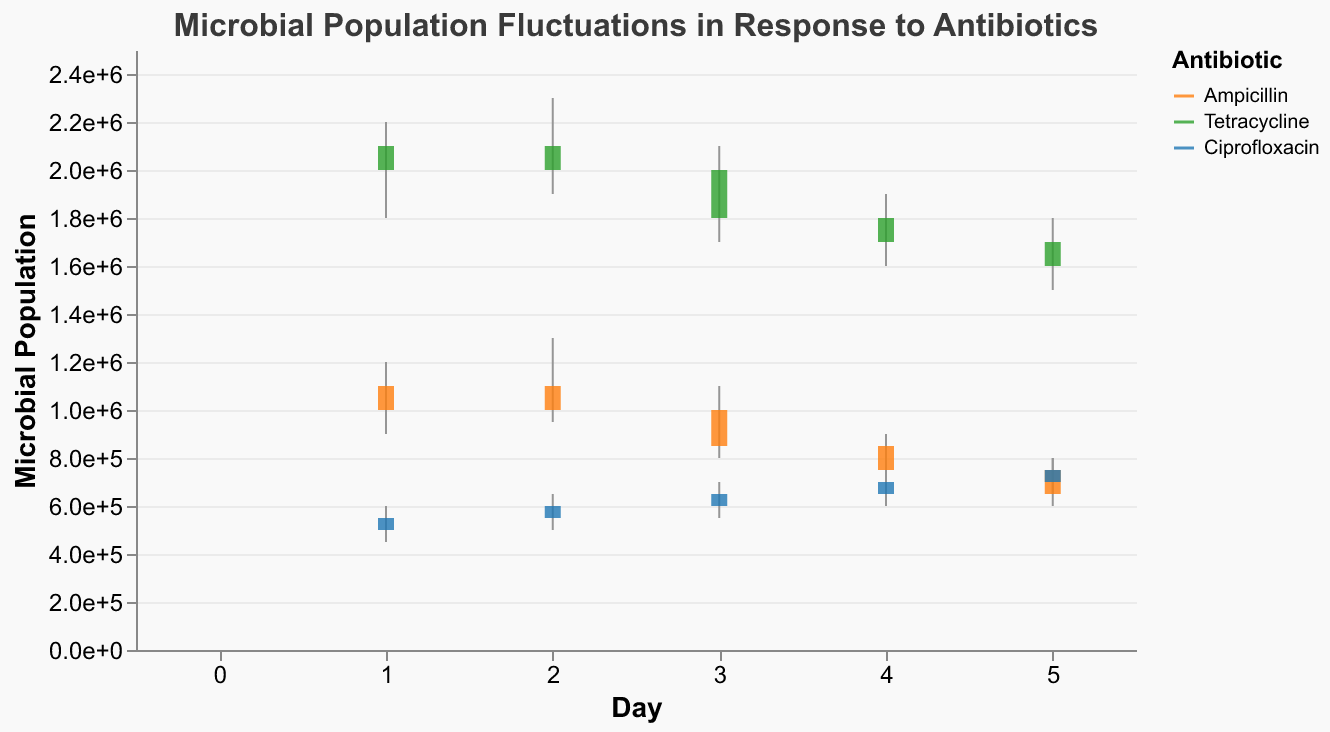What's the title of the figure? The title is prominently displayed at the top of the figure.
Answer: Microbial Population Fluctuations in Response to Antibiotics Which antibiotic has the highest initial microbial population on Day 1? On Day 1, Tetracycline has the highest open value.
Answer: Tetracycline What is the closing population density for Ciprofloxacin on Day 3? The close value for Ciprofloxacin on Day 3 is displayed in the figure.
Answer: 650,000 Between Ampicillin and Tetracycline, which antibiotic shows a greater reduction in microbial population density by Day 5? Ampicillin starts from 1,000,000 on Day 1 and ends at 650,000 on Day 5. Tetracycline starts from 2,000,000 on Day 1 and ends at 1,600,000 on Day 5. The reduction for Ampicillin is 350,000 and for Tetracycline is 400,000.
Answer: Tetracycline What is the lowest recorded microbial population density for Ampicillin throughout the days? The lowest recorded value is the low value for Ampicillin across all days, which is 600,000 on Day 5.
Answer: 600,000 Which antibiotic shows the most consistent population density across the days? Ciprofloxacin shows a steady increase in both open and close values each day from Day 1 to Day 5.
Answer: Ciprofloxacin On which day does Tetracycline have its highest microbial population? On Day 2, Tetracycline's high value reaches 2,300,000, which is its highest.
Answer: Day 2 What is the difference between the highest population density and the lowest population density for Ciprofloxacin on Day 1? The high is 600,000 and the low is 450,000 for Ciprofloxacin on Day 1. The difference is 600,000 - 450,000 = 150,000.
Answer: 150,000 Which antibiotic has the largest range of fluctuations on Day 1? Tetracycline has a range of 400,000 (high of 2,200,000 and low of 1,800,000) on Day 1, which is the largest range compared to the other antibiotics.
Answer: Tetracycline What trend is observed in the microbial population density for Ciprofloxacin over the 5 days? Ciprofloxacin shows a consistent increasing trend in both the open and close values over the 5 days.
Answer: Increasing trend 